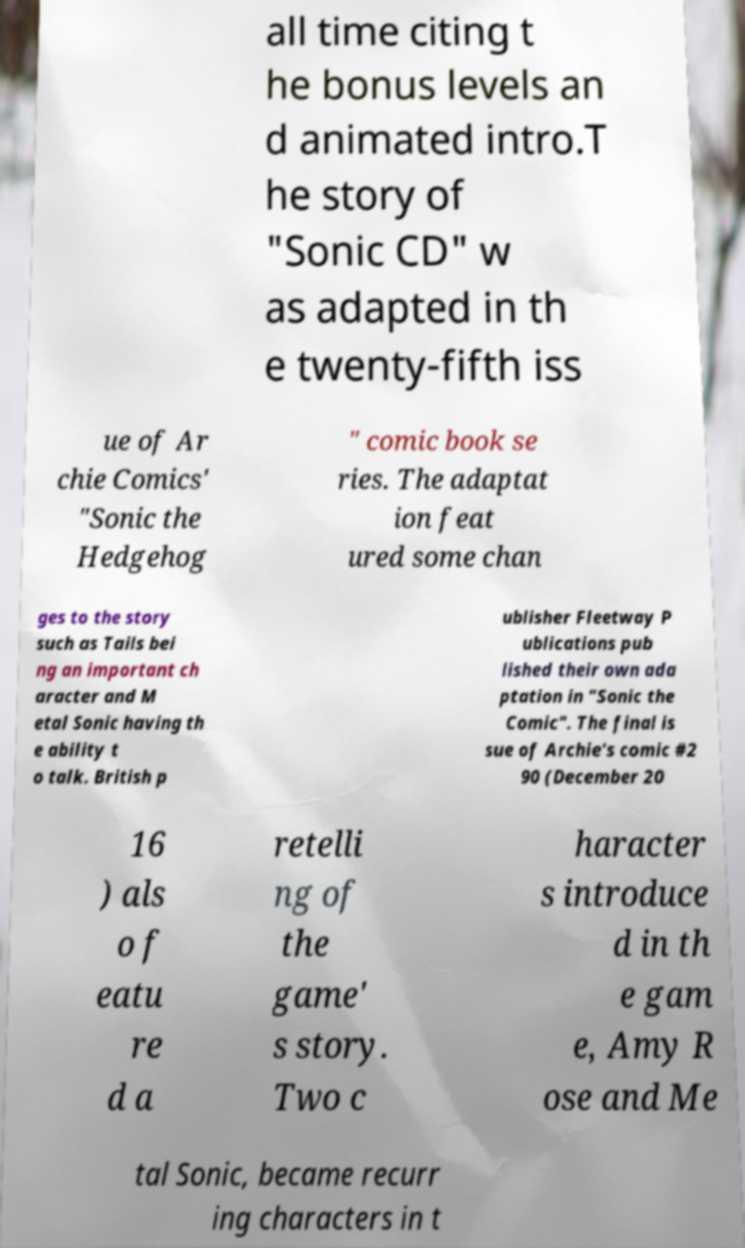Can you read and provide the text displayed in the image?This photo seems to have some interesting text. Can you extract and type it out for me? all time citing t he bonus levels an d animated intro.T he story of "Sonic CD" w as adapted in th e twenty-fifth iss ue of Ar chie Comics' "Sonic the Hedgehog " comic book se ries. The adaptat ion feat ured some chan ges to the story such as Tails bei ng an important ch aracter and M etal Sonic having th e ability t o talk. British p ublisher Fleetway P ublications pub lished their own ada ptation in "Sonic the Comic". The final is sue of Archie's comic #2 90 (December 20 16 ) als o f eatu re d a retelli ng of the game' s story. Two c haracter s introduce d in th e gam e, Amy R ose and Me tal Sonic, became recurr ing characters in t 